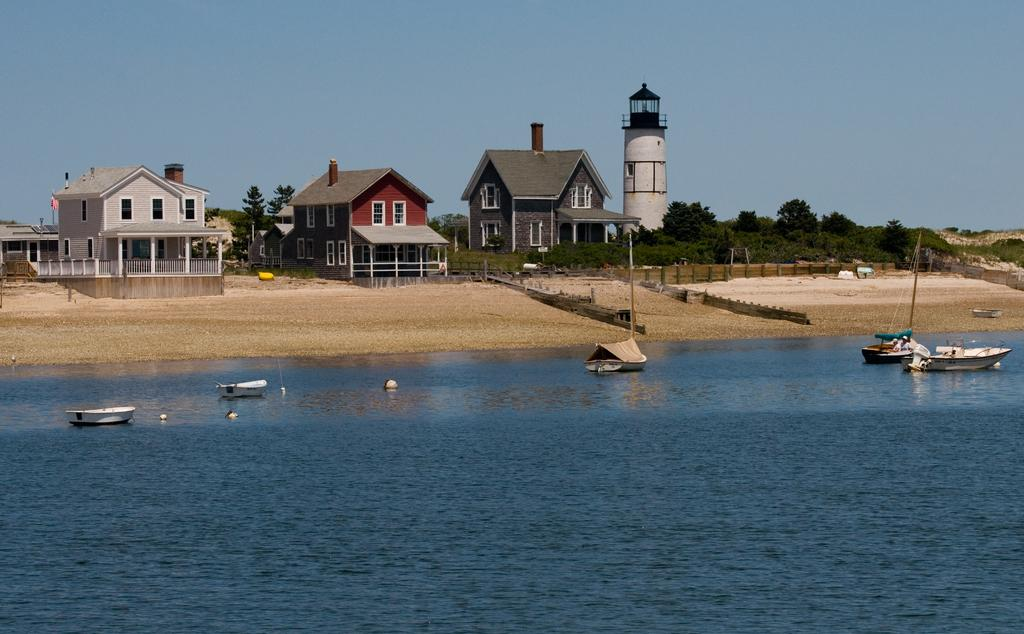What can be seen on the surface of the water in the foreground? There are boats on the surface of water in the foreground. What structures are visible in the background? There are houses, trees, and a tower in the background. What is visible in the sky in the background? The sky is visible in the background. What type of bike is featured in the scene? There is no bike present in the image; it features boats on the water and structures in the background. What does the caption say about the scene? There is no caption provided with the image, so it cannot be determined what the caption might say. 